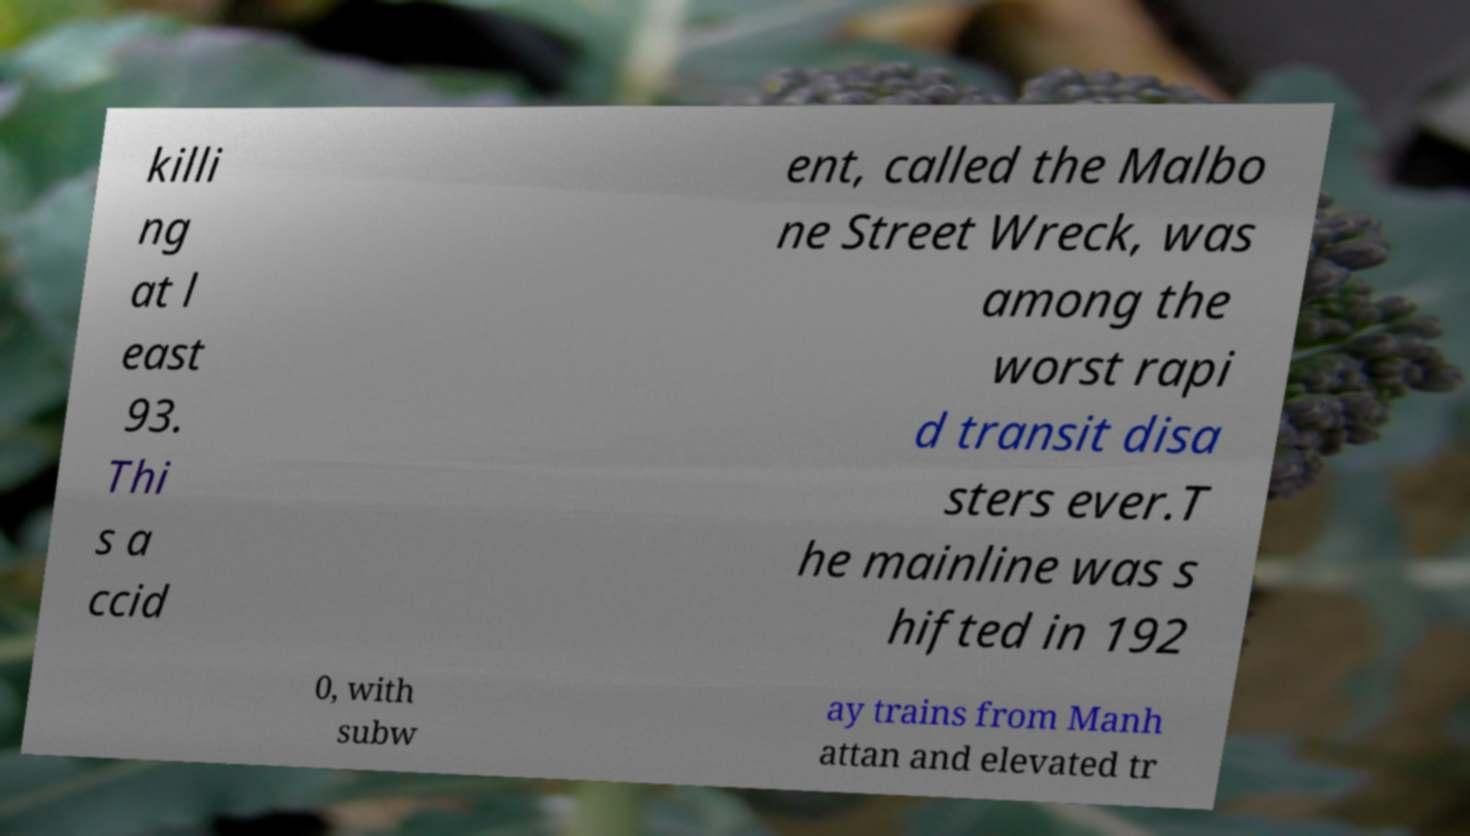Can you accurately transcribe the text from the provided image for me? killi ng at l east 93. Thi s a ccid ent, called the Malbo ne Street Wreck, was among the worst rapi d transit disa sters ever.T he mainline was s hifted in 192 0, with subw ay trains from Manh attan and elevated tr 